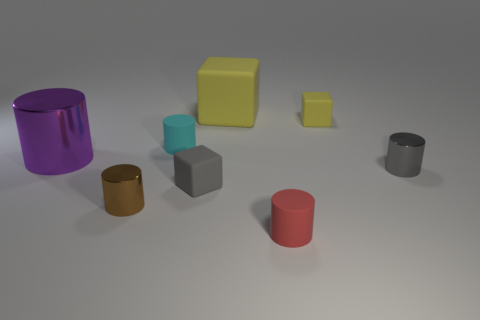What number of balls are either yellow rubber things or small red matte things?
Your answer should be very brief. 0. There is a gray thing that is to the left of the small gray metallic cylinder; is it the same size as the cylinder in front of the small brown object?
Your answer should be compact. Yes. The yellow block that is in front of the large thing that is on the right side of the tiny brown thing is made of what material?
Make the answer very short. Rubber. Is the number of tiny metal objects left of the tiny yellow matte cube less than the number of metal cylinders?
Provide a succinct answer. Yes. What is the shape of the cyan thing that is made of the same material as the red cylinder?
Offer a terse response. Cylinder. How many other objects are the same shape as the red thing?
Make the answer very short. 4. What number of gray things are matte things or small matte things?
Ensure brevity in your answer.  1. Does the purple object have the same shape as the small gray shiny thing?
Give a very brief answer. Yes. Is there a cylinder left of the rubber cube that is in front of the big shiny cylinder?
Your answer should be compact. Yes. Are there an equal number of yellow things in front of the big yellow block and tiny brown things?
Give a very brief answer. Yes. 